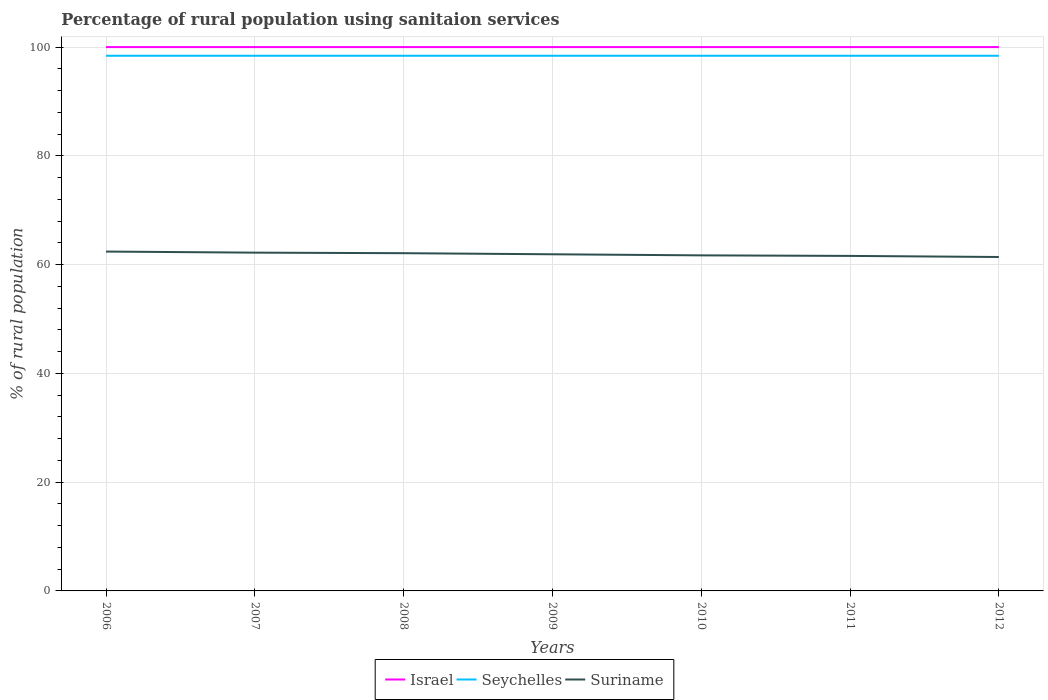Is the number of lines equal to the number of legend labels?
Offer a very short reply. Yes. Across all years, what is the maximum percentage of rural population using sanitaion services in Israel?
Ensure brevity in your answer.  100. In which year was the percentage of rural population using sanitaion services in Israel maximum?
Make the answer very short. 2006. What is the total percentage of rural population using sanitaion services in Israel in the graph?
Offer a terse response. 0. What is the difference between two consecutive major ticks on the Y-axis?
Keep it short and to the point. 20. Are the values on the major ticks of Y-axis written in scientific E-notation?
Provide a short and direct response. No. Does the graph contain grids?
Your answer should be compact. Yes. Where does the legend appear in the graph?
Your answer should be compact. Bottom center. How are the legend labels stacked?
Your answer should be compact. Horizontal. What is the title of the graph?
Keep it short and to the point. Percentage of rural population using sanitaion services. Does "Italy" appear as one of the legend labels in the graph?
Give a very brief answer. No. What is the label or title of the Y-axis?
Your answer should be very brief. % of rural population. What is the % of rural population of Seychelles in 2006?
Give a very brief answer. 98.4. What is the % of rural population of Suriname in 2006?
Keep it short and to the point. 62.4. What is the % of rural population of Israel in 2007?
Your answer should be very brief. 100. What is the % of rural population of Seychelles in 2007?
Offer a terse response. 98.4. What is the % of rural population of Suriname in 2007?
Offer a very short reply. 62.2. What is the % of rural population of Seychelles in 2008?
Keep it short and to the point. 98.4. What is the % of rural population in Suriname in 2008?
Provide a short and direct response. 62.1. What is the % of rural population in Seychelles in 2009?
Your response must be concise. 98.4. What is the % of rural population in Suriname in 2009?
Your answer should be compact. 61.9. What is the % of rural population of Seychelles in 2010?
Offer a terse response. 98.4. What is the % of rural population of Suriname in 2010?
Offer a very short reply. 61.7. What is the % of rural population in Israel in 2011?
Your answer should be compact. 100. What is the % of rural population in Seychelles in 2011?
Keep it short and to the point. 98.4. What is the % of rural population in Suriname in 2011?
Offer a terse response. 61.6. What is the % of rural population in Seychelles in 2012?
Provide a succinct answer. 98.4. What is the % of rural population in Suriname in 2012?
Offer a terse response. 61.4. Across all years, what is the maximum % of rural population of Seychelles?
Keep it short and to the point. 98.4. Across all years, what is the maximum % of rural population of Suriname?
Give a very brief answer. 62.4. Across all years, what is the minimum % of rural population of Israel?
Make the answer very short. 100. Across all years, what is the minimum % of rural population in Seychelles?
Offer a terse response. 98.4. Across all years, what is the minimum % of rural population in Suriname?
Offer a very short reply. 61.4. What is the total % of rural population in Israel in the graph?
Give a very brief answer. 700. What is the total % of rural population in Seychelles in the graph?
Keep it short and to the point. 688.8. What is the total % of rural population in Suriname in the graph?
Ensure brevity in your answer.  433.3. What is the difference between the % of rural population in Seychelles in 2006 and that in 2007?
Make the answer very short. 0. What is the difference between the % of rural population of Suriname in 2006 and that in 2007?
Provide a succinct answer. 0.2. What is the difference between the % of rural population of Israel in 2006 and that in 2008?
Provide a succinct answer. 0. What is the difference between the % of rural population in Seychelles in 2006 and that in 2009?
Give a very brief answer. 0. What is the difference between the % of rural population of Suriname in 2006 and that in 2009?
Make the answer very short. 0.5. What is the difference between the % of rural population in Israel in 2006 and that in 2011?
Keep it short and to the point. 0. What is the difference between the % of rural population of Seychelles in 2006 and that in 2011?
Offer a very short reply. 0. What is the difference between the % of rural population of Seychelles in 2006 and that in 2012?
Provide a succinct answer. 0. What is the difference between the % of rural population of Suriname in 2006 and that in 2012?
Offer a very short reply. 1. What is the difference between the % of rural population in Israel in 2007 and that in 2008?
Provide a succinct answer. 0. What is the difference between the % of rural population of Seychelles in 2007 and that in 2008?
Provide a short and direct response. 0. What is the difference between the % of rural population of Suriname in 2007 and that in 2008?
Provide a succinct answer. 0.1. What is the difference between the % of rural population of Seychelles in 2007 and that in 2009?
Provide a succinct answer. 0. What is the difference between the % of rural population of Israel in 2007 and that in 2010?
Offer a terse response. 0. What is the difference between the % of rural population in Suriname in 2007 and that in 2012?
Keep it short and to the point. 0.8. What is the difference between the % of rural population of Suriname in 2008 and that in 2009?
Your response must be concise. 0.2. What is the difference between the % of rural population in Israel in 2008 and that in 2010?
Make the answer very short. 0. What is the difference between the % of rural population in Suriname in 2008 and that in 2010?
Provide a succinct answer. 0.4. What is the difference between the % of rural population in Suriname in 2008 and that in 2011?
Your answer should be very brief. 0.5. What is the difference between the % of rural population of Israel in 2008 and that in 2012?
Provide a short and direct response. 0. What is the difference between the % of rural population of Seychelles in 2008 and that in 2012?
Ensure brevity in your answer.  0. What is the difference between the % of rural population of Suriname in 2008 and that in 2012?
Offer a very short reply. 0.7. What is the difference between the % of rural population of Israel in 2009 and that in 2010?
Your answer should be compact. 0. What is the difference between the % of rural population in Seychelles in 2009 and that in 2010?
Provide a short and direct response. 0. What is the difference between the % of rural population of Suriname in 2009 and that in 2010?
Offer a terse response. 0.2. What is the difference between the % of rural population in Israel in 2009 and that in 2011?
Keep it short and to the point. 0. What is the difference between the % of rural population of Seychelles in 2009 and that in 2011?
Keep it short and to the point. 0. What is the difference between the % of rural population of Suriname in 2009 and that in 2011?
Provide a succinct answer. 0.3. What is the difference between the % of rural population in Suriname in 2010 and that in 2011?
Give a very brief answer. 0.1. What is the difference between the % of rural population in Israel in 2011 and that in 2012?
Ensure brevity in your answer.  0. What is the difference between the % of rural population of Seychelles in 2011 and that in 2012?
Provide a succinct answer. 0. What is the difference between the % of rural population in Israel in 2006 and the % of rural population in Seychelles in 2007?
Your response must be concise. 1.6. What is the difference between the % of rural population of Israel in 2006 and the % of rural population of Suriname in 2007?
Provide a succinct answer. 37.8. What is the difference between the % of rural population of Seychelles in 2006 and the % of rural population of Suriname in 2007?
Ensure brevity in your answer.  36.2. What is the difference between the % of rural population in Israel in 2006 and the % of rural population in Suriname in 2008?
Make the answer very short. 37.9. What is the difference between the % of rural population of Seychelles in 2006 and the % of rural population of Suriname in 2008?
Make the answer very short. 36.3. What is the difference between the % of rural population in Israel in 2006 and the % of rural population in Suriname in 2009?
Offer a terse response. 38.1. What is the difference between the % of rural population in Seychelles in 2006 and the % of rural population in Suriname in 2009?
Your answer should be very brief. 36.5. What is the difference between the % of rural population of Israel in 2006 and the % of rural population of Suriname in 2010?
Offer a very short reply. 38.3. What is the difference between the % of rural population in Seychelles in 2006 and the % of rural population in Suriname in 2010?
Your answer should be compact. 36.7. What is the difference between the % of rural population of Israel in 2006 and the % of rural population of Seychelles in 2011?
Offer a very short reply. 1.6. What is the difference between the % of rural population of Israel in 2006 and the % of rural population of Suriname in 2011?
Make the answer very short. 38.4. What is the difference between the % of rural population in Seychelles in 2006 and the % of rural population in Suriname in 2011?
Ensure brevity in your answer.  36.8. What is the difference between the % of rural population of Israel in 2006 and the % of rural population of Suriname in 2012?
Give a very brief answer. 38.6. What is the difference between the % of rural population of Israel in 2007 and the % of rural population of Suriname in 2008?
Offer a terse response. 37.9. What is the difference between the % of rural population of Seychelles in 2007 and the % of rural population of Suriname in 2008?
Keep it short and to the point. 36.3. What is the difference between the % of rural population of Israel in 2007 and the % of rural population of Seychelles in 2009?
Provide a succinct answer. 1.6. What is the difference between the % of rural population in Israel in 2007 and the % of rural population in Suriname in 2009?
Your answer should be compact. 38.1. What is the difference between the % of rural population of Seychelles in 2007 and the % of rural population of Suriname in 2009?
Keep it short and to the point. 36.5. What is the difference between the % of rural population of Israel in 2007 and the % of rural population of Suriname in 2010?
Your answer should be very brief. 38.3. What is the difference between the % of rural population of Seychelles in 2007 and the % of rural population of Suriname in 2010?
Ensure brevity in your answer.  36.7. What is the difference between the % of rural population in Israel in 2007 and the % of rural population in Suriname in 2011?
Give a very brief answer. 38.4. What is the difference between the % of rural population in Seychelles in 2007 and the % of rural population in Suriname in 2011?
Offer a very short reply. 36.8. What is the difference between the % of rural population of Israel in 2007 and the % of rural population of Seychelles in 2012?
Your answer should be very brief. 1.6. What is the difference between the % of rural population in Israel in 2007 and the % of rural population in Suriname in 2012?
Keep it short and to the point. 38.6. What is the difference between the % of rural population in Israel in 2008 and the % of rural population in Seychelles in 2009?
Offer a very short reply. 1.6. What is the difference between the % of rural population of Israel in 2008 and the % of rural population of Suriname in 2009?
Make the answer very short. 38.1. What is the difference between the % of rural population in Seychelles in 2008 and the % of rural population in Suriname in 2009?
Make the answer very short. 36.5. What is the difference between the % of rural population in Israel in 2008 and the % of rural population in Seychelles in 2010?
Keep it short and to the point. 1.6. What is the difference between the % of rural population of Israel in 2008 and the % of rural population of Suriname in 2010?
Give a very brief answer. 38.3. What is the difference between the % of rural population in Seychelles in 2008 and the % of rural population in Suriname in 2010?
Provide a short and direct response. 36.7. What is the difference between the % of rural population of Israel in 2008 and the % of rural population of Seychelles in 2011?
Give a very brief answer. 1.6. What is the difference between the % of rural population of Israel in 2008 and the % of rural population of Suriname in 2011?
Offer a terse response. 38.4. What is the difference between the % of rural population in Seychelles in 2008 and the % of rural population in Suriname in 2011?
Keep it short and to the point. 36.8. What is the difference between the % of rural population of Israel in 2008 and the % of rural population of Seychelles in 2012?
Your answer should be compact. 1.6. What is the difference between the % of rural population in Israel in 2008 and the % of rural population in Suriname in 2012?
Provide a succinct answer. 38.6. What is the difference between the % of rural population in Seychelles in 2008 and the % of rural population in Suriname in 2012?
Make the answer very short. 37. What is the difference between the % of rural population in Israel in 2009 and the % of rural population in Seychelles in 2010?
Make the answer very short. 1.6. What is the difference between the % of rural population of Israel in 2009 and the % of rural population of Suriname in 2010?
Give a very brief answer. 38.3. What is the difference between the % of rural population in Seychelles in 2009 and the % of rural population in Suriname in 2010?
Give a very brief answer. 36.7. What is the difference between the % of rural population of Israel in 2009 and the % of rural population of Seychelles in 2011?
Provide a succinct answer. 1.6. What is the difference between the % of rural population in Israel in 2009 and the % of rural population in Suriname in 2011?
Your answer should be very brief. 38.4. What is the difference between the % of rural population of Seychelles in 2009 and the % of rural population of Suriname in 2011?
Make the answer very short. 36.8. What is the difference between the % of rural population of Israel in 2009 and the % of rural population of Suriname in 2012?
Give a very brief answer. 38.6. What is the difference between the % of rural population of Seychelles in 2009 and the % of rural population of Suriname in 2012?
Keep it short and to the point. 37. What is the difference between the % of rural population in Israel in 2010 and the % of rural population in Suriname in 2011?
Make the answer very short. 38.4. What is the difference between the % of rural population of Seychelles in 2010 and the % of rural population of Suriname in 2011?
Your response must be concise. 36.8. What is the difference between the % of rural population in Israel in 2010 and the % of rural population in Suriname in 2012?
Your response must be concise. 38.6. What is the difference between the % of rural population in Israel in 2011 and the % of rural population in Seychelles in 2012?
Make the answer very short. 1.6. What is the difference between the % of rural population of Israel in 2011 and the % of rural population of Suriname in 2012?
Give a very brief answer. 38.6. What is the difference between the % of rural population in Seychelles in 2011 and the % of rural population in Suriname in 2012?
Keep it short and to the point. 37. What is the average % of rural population in Israel per year?
Provide a short and direct response. 100. What is the average % of rural population of Seychelles per year?
Your answer should be very brief. 98.4. What is the average % of rural population of Suriname per year?
Keep it short and to the point. 61.9. In the year 2006, what is the difference between the % of rural population of Israel and % of rural population of Suriname?
Provide a short and direct response. 37.6. In the year 2006, what is the difference between the % of rural population in Seychelles and % of rural population in Suriname?
Your answer should be compact. 36. In the year 2007, what is the difference between the % of rural population of Israel and % of rural population of Seychelles?
Your answer should be very brief. 1.6. In the year 2007, what is the difference between the % of rural population in Israel and % of rural population in Suriname?
Offer a very short reply. 37.8. In the year 2007, what is the difference between the % of rural population of Seychelles and % of rural population of Suriname?
Provide a short and direct response. 36.2. In the year 2008, what is the difference between the % of rural population in Israel and % of rural population in Suriname?
Make the answer very short. 37.9. In the year 2008, what is the difference between the % of rural population in Seychelles and % of rural population in Suriname?
Offer a very short reply. 36.3. In the year 2009, what is the difference between the % of rural population in Israel and % of rural population in Suriname?
Provide a short and direct response. 38.1. In the year 2009, what is the difference between the % of rural population of Seychelles and % of rural population of Suriname?
Ensure brevity in your answer.  36.5. In the year 2010, what is the difference between the % of rural population in Israel and % of rural population in Seychelles?
Your response must be concise. 1.6. In the year 2010, what is the difference between the % of rural population of Israel and % of rural population of Suriname?
Your answer should be compact. 38.3. In the year 2010, what is the difference between the % of rural population in Seychelles and % of rural population in Suriname?
Make the answer very short. 36.7. In the year 2011, what is the difference between the % of rural population of Israel and % of rural population of Seychelles?
Provide a succinct answer. 1.6. In the year 2011, what is the difference between the % of rural population in Israel and % of rural population in Suriname?
Provide a succinct answer. 38.4. In the year 2011, what is the difference between the % of rural population of Seychelles and % of rural population of Suriname?
Provide a succinct answer. 36.8. In the year 2012, what is the difference between the % of rural population of Israel and % of rural population of Suriname?
Your answer should be compact. 38.6. In the year 2012, what is the difference between the % of rural population in Seychelles and % of rural population in Suriname?
Make the answer very short. 37. What is the ratio of the % of rural population in Israel in 2006 to that in 2007?
Provide a succinct answer. 1. What is the ratio of the % of rural population of Seychelles in 2006 to that in 2007?
Provide a succinct answer. 1. What is the ratio of the % of rural population of Israel in 2006 to that in 2008?
Provide a short and direct response. 1. What is the ratio of the % of rural population of Seychelles in 2006 to that in 2008?
Your answer should be compact. 1. What is the ratio of the % of rural population of Suriname in 2006 to that in 2008?
Ensure brevity in your answer.  1. What is the ratio of the % of rural population of Suriname in 2006 to that in 2010?
Give a very brief answer. 1.01. What is the ratio of the % of rural population in Israel in 2006 to that in 2011?
Keep it short and to the point. 1. What is the ratio of the % of rural population in Suriname in 2006 to that in 2011?
Your response must be concise. 1.01. What is the ratio of the % of rural population of Israel in 2006 to that in 2012?
Provide a short and direct response. 1. What is the ratio of the % of rural population of Seychelles in 2006 to that in 2012?
Provide a short and direct response. 1. What is the ratio of the % of rural population in Suriname in 2006 to that in 2012?
Keep it short and to the point. 1.02. What is the ratio of the % of rural population of Israel in 2007 to that in 2008?
Keep it short and to the point. 1. What is the ratio of the % of rural population in Israel in 2007 to that in 2009?
Offer a terse response. 1. What is the ratio of the % of rural population of Suriname in 2007 to that in 2009?
Your answer should be very brief. 1. What is the ratio of the % of rural population of Israel in 2007 to that in 2010?
Your answer should be compact. 1. What is the ratio of the % of rural population of Seychelles in 2007 to that in 2010?
Offer a terse response. 1. What is the ratio of the % of rural population in Suriname in 2007 to that in 2011?
Provide a succinct answer. 1.01. What is the ratio of the % of rural population of Israel in 2007 to that in 2012?
Offer a terse response. 1. What is the ratio of the % of rural population of Israel in 2008 to that in 2009?
Give a very brief answer. 1. What is the ratio of the % of rural population in Seychelles in 2008 to that in 2009?
Your response must be concise. 1. What is the ratio of the % of rural population in Israel in 2008 to that in 2010?
Your answer should be compact. 1. What is the ratio of the % of rural population of Seychelles in 2008 to that in 2010?
Your answer should be compact. 1. What is the ratio of the % of rural population of Suriname in 2008 to that in 2010?
Offer a terse response. 1.01. What is the ratio of the % of rural population of Suriname in 2008 to that in 2011?
Your answer should be very brief. 1.01. What is the ratio of the % of rural population in Israel in 2008 to that in 2012?
Make the answer very short. 1. What is the ratio of the % of rural population of Seychelles in 2008 to that in 2012?
Keep it short and to the point. 1. What is the ratio of the % of rural population of Suriname in 2008 to that in 2012?
Offer a very short reply. 1.01. What is the ratio of the % of rural population in Israel in 2009 to that in 2010?
Offer a very short reply. 1. What is the ratio of the % of rural population of Seychelles in 2009 to that in 2010?
Provide a short and direct response. 1. What is the ratio of the % of rural population in Suriname in 2009 to that in 2010?
Your answer should be compact. 1. What is the ratio of the % of rural population of Seychelles in 2009 to that in 2011?
Give a very brief answer. 1. What is the ratio of the % of rural population of Israel in 2009 to that in 2012?
Your answer should be very brief. 1. What is the ratio of the % of rural population of Seychelles in 2009 to that in 2012?
Provide a succinct answer. 1. What is the ratio of the % of rural population in Seychelles in 2010 to that in 2012?
Keep it short and to the point. 1. What is the ratio of the % of rural population in Suriname in 2010 to that in 2012?
Ensure brevity in your answer.  1. What is the ratio of the % of rural population in Israel in 2011 to that in 2012?
Your answer should be very brief. 1. What is the ratio of the % of rural population of Seychelles in 2011 to that in 2012?
Offer a very short reply. 1. What is the ratio of the % of rural population in Suriname in 2011 to that in 2012?
Provide a short and direct response. 1. What is the difference between the highest and the second highest % of rural population in Seychelles?
Make the answer very short. 0. What is the difference between the highest and the lowest % of rural population in Seychelles?
Ensure brevity in your answer.  0. What is the difference between the highest and the lowest % of rural population of Suriname?
Ensure brevity in your answer.  1. 